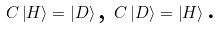<formula> <loc_0><loc_0><loc_500><loc_500>C \left | H \right \rangle = \left | D \right \rangle \text {, } C \left | D \right \rangle = \left | H \right \rangle \text {. }</formula> 